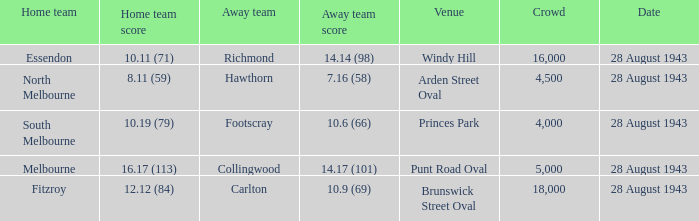Where was the game played with an away team score of 14.17 (101)? Punt Road Oval. 